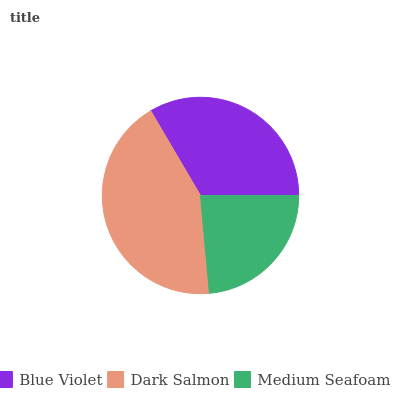Is Medium Seafoam the minimum?
Answer yes or no. Yes. Is Dark Salmon the maximum?
Answer yes or no. Yes. Is Dark Salmon the minimum?
Answer yes or no. No. Is Medium Seafoam the maximum?
Answer yes or no. No. Is Dark Salmon greater than Medium Seafoam?
Answer yes or no. Yes. Is Medium Seafoam less than Dark Salmon?
Answer yes or no. Yes. Is Medium Seafoam greater than Dark Salmon?
Answer yes or no. No. Is Dark Salmon less than Medium Seafoam?
Answer yes or no. No. Is Blue Violet the high median?
Answer yes or no. Yes. Is Blue Violet the low median?
Answer yes or no. Yes. Is Medium Seafoam the high median?
Answer yes or no. No. Is Medium Seafoam the low median?
Answer yes or no. No. 